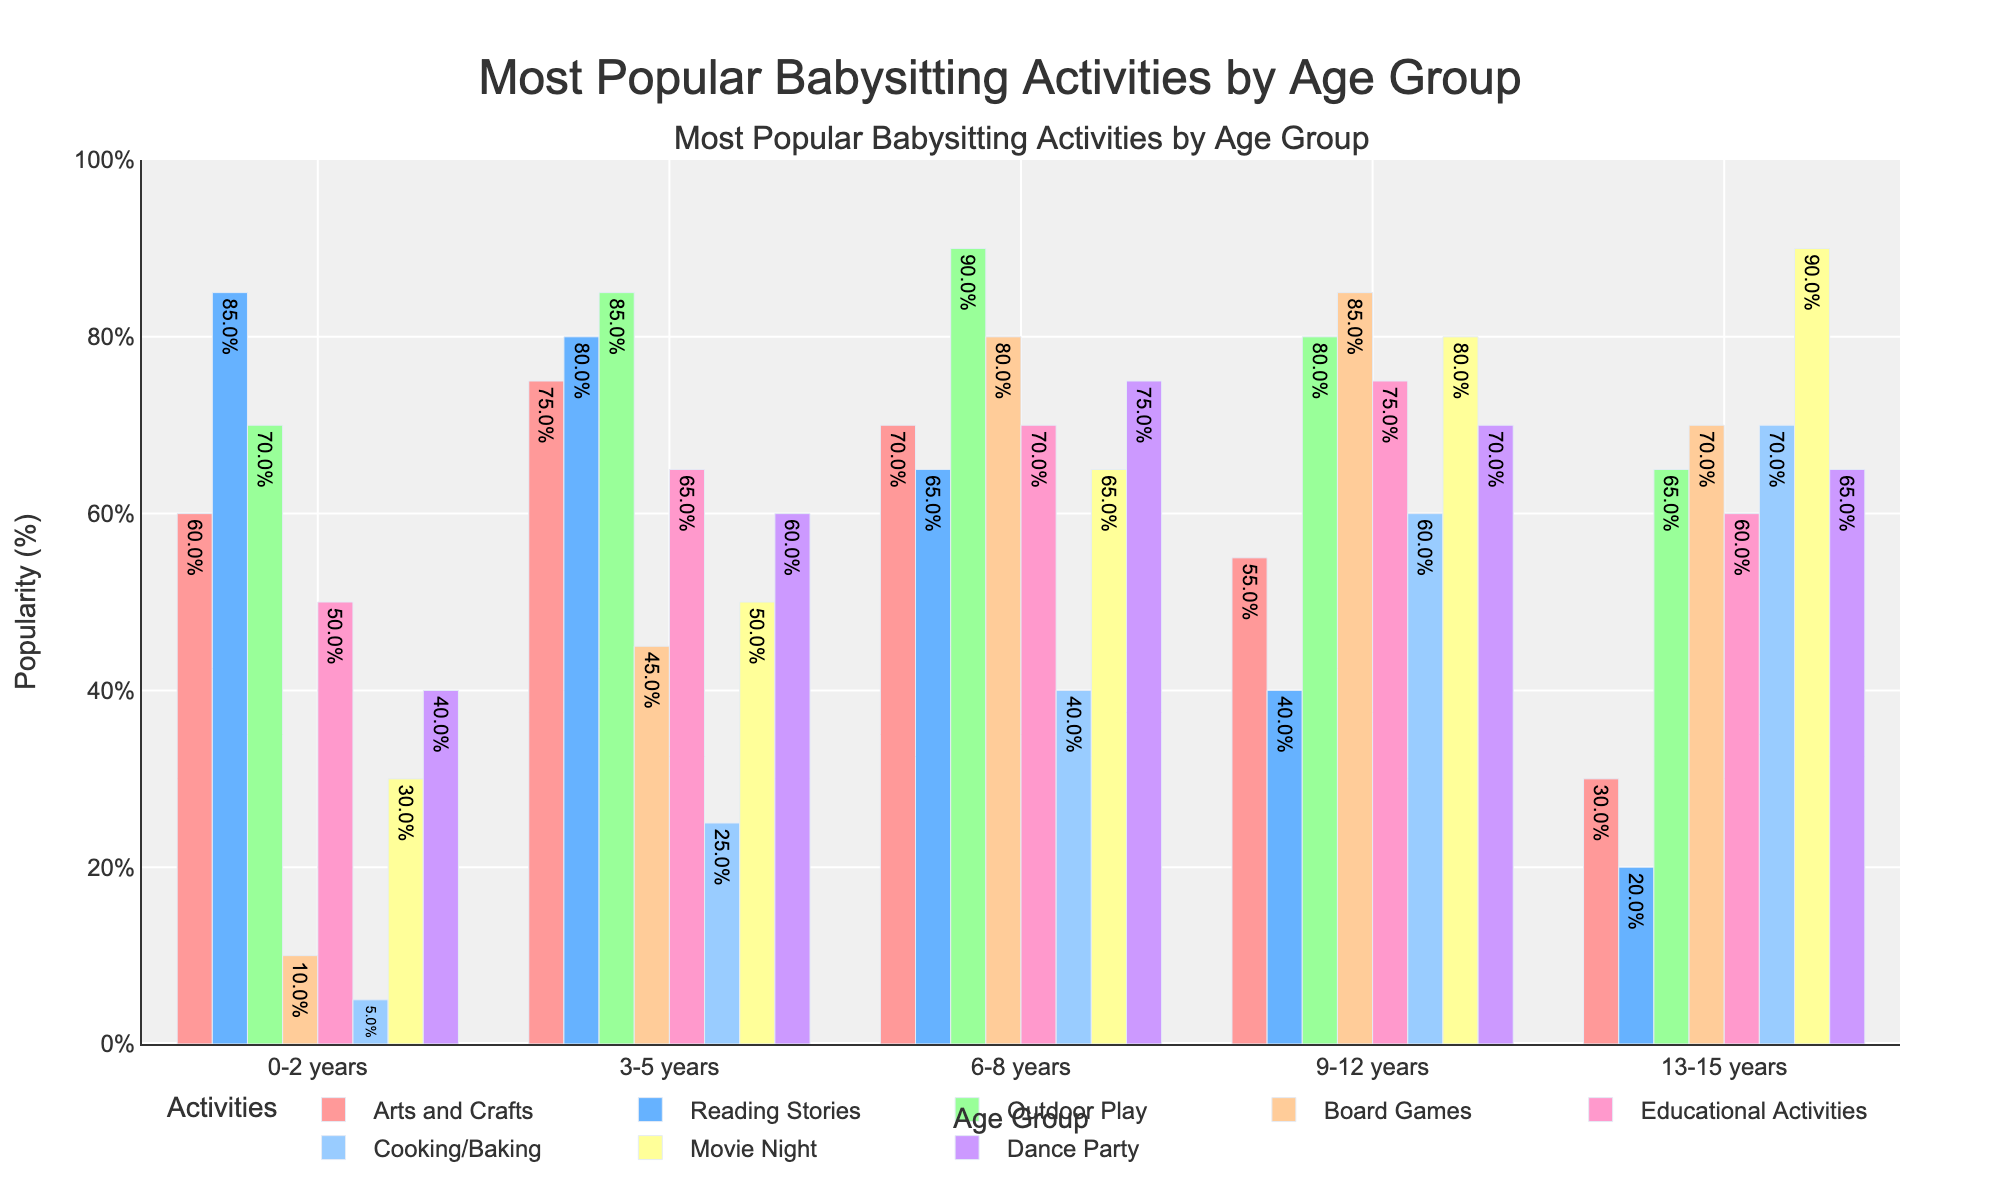What activity is the most popular for the 0-2 years age group? The figure shows that Reading Stories has the highest percentage for the 0-2 years age group with 85%.
Answer: Reading Stories Which age group has the highest popularity percentage for Cooking/Baking? By comparing the bars for Cooking/Baking across all age groups, the 13-15 years group has the highest percentage at 70%.
Answer: 13-15 years How does the popularity of Board Games change as children get older? Looking at the bars for Board Games across age groups, the popularity increases: 10% (0-2 years), 45% (3-5 years), 80% (6-8 years), 85% (9-12 years), then slightly decreases to 70% (13-15 years).
Answer: Increases, peaking at 9-12 years, then slight decrease Compare the popularity of Outdoor Play between the 3-5 years and 6-8 years age groups. The figure shows that the popularity of Outdoor Play is 85% for the 3-5 years group and 90% for the 6-8 years group.
Answer: 6-8 years higher by 5% What's the difference in the popularity percentage of Dance Party between the youngest and oldest age groups? The figure shows that Dance Party has 40% popularity in the 0-2 years group and 65% in the 13-15 years group. Subtracting these values gives a difference of 25%.
Answer: 25% Find the average popularity percentage of Educational Activities across all age groups. The percentages for Educational Activities are 50%, 65%, 70%, 75%, and 60%. Sum these (50 + 65 + 70 + 75 + 60 = 320) and divide by the number of age groups (5), resulting in 64%.
Answer: 64% What is the least popular activity for the 9-12 years age group? By comparing the bars for various activities in the 9-12 years group, Reading Stories has the lowest percentage at 40%.
Answer: Reading Stories 